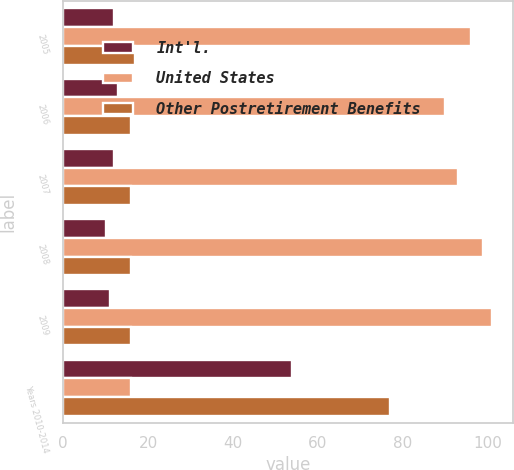<chart> <loc_0><loc_0><loc_500><loc_500><stacked_bar_chart><ecel><fcel>2005<fcel>2006<fcel>2007<fcel>2008<fcel>2009<fcel>Years 2010-2014<nl><fcel>Int'l.<fcel>12<fcel>13<fcel>12<fcel>10<fcel>11<fcel>54<nl><fcel>United States<fcel>96<fcel>90<fcel>93<fcel>99<fcel>101<fcel>16<nl><fcel>Other Postretirement Benefits<fcel>17<fcel>16<fcel>16<fcel>16<fcel>16<fcel>77<nl></chart> 